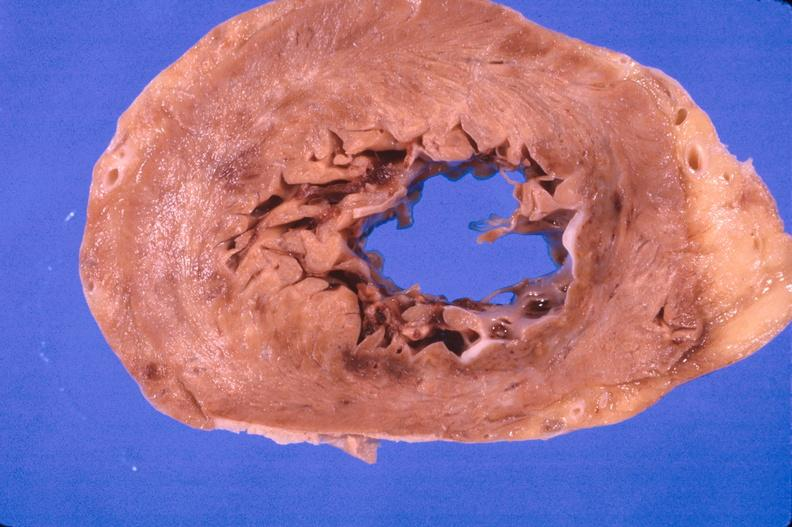what does this image show?
Answer the question using a single word or phrase. Heart 